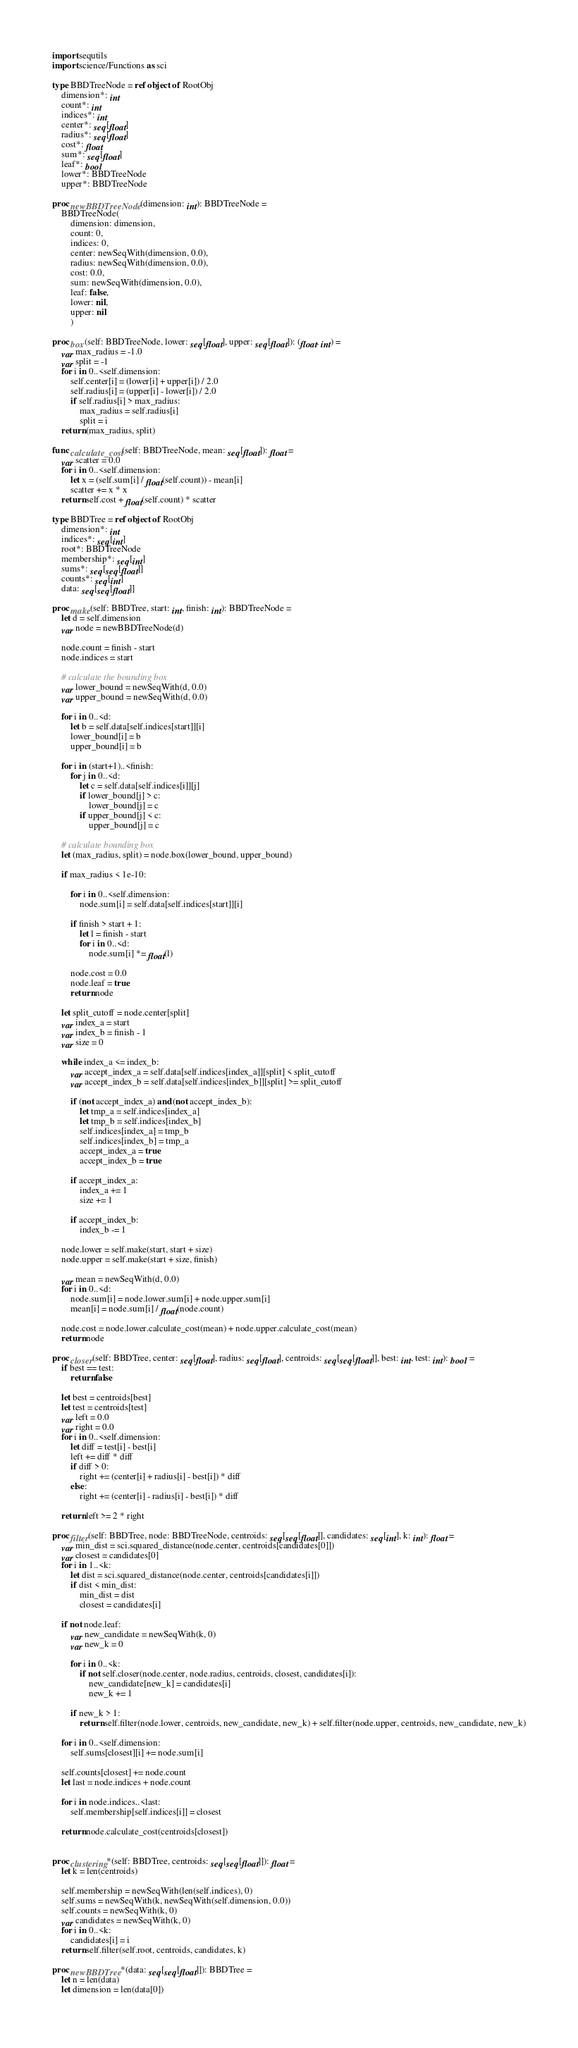<code> <loc_0><loc_0><loc_500><loc_500><_Nim_>import sequtils
import science/Functions as sci

type BBDTreeNode = ref object of RootObj
    dimension*: int
    count*: int
    indices*: int
    center*: seq[float]
    radius*: seq[float]
    cost*: float
    sum*: seq[float]
    leaf*: bool
    lower*: BBDTreeNode
    upper*: BBDTreeNode

proc newBBDTreeNode(dimension: int): BBDTreeNode =
    BBDTreeNode(
        dimension: dimension,
        count: 0,
        indices: 0,
        center: newSeqWith(dimension, 0.0),
        radius: newSeqWith(dimension, 0.0),
        cost: 0.0,
        sum: newSeqWith(dimension, 0.0),
        leaf: false,
        lower: nil,
        upper: nil
        )

proc box(self: BBDTreeNode, lower: seq[float], upper: seq[float]): (float, int) =
    var max_radius = -1.0
    var split = -1
    for i in 0..<self.dimension:
        self.center[i] = (lower[i] + upper[i]) / 2.0
        self.radius[i] = (upper[i] - lower[i]) / 2.0
        if self.radius[i] > max_radius:
            max_radius = self.radius[i]
            split = i
    return (max_radius, split)

func calculate_cost(self: BBDTreeNode, mean: seq[float]): float =
    var scatter = 0.0
    for i in 0..<self.dimension:
        let x = (self.sum[i] / float(self.count)) - mean[i]
        scatter += x * x
    return self.cost + float(self.count) * scatter

type BBDTree = ref object of RootObj
    dimension*: int
    indices*: seq[int]
    root*: BBDTreeNode
    membership*: seq[int]
    sums*: seq[seq[float]]
    counts*: seq[int]
    data: seq[seq[float]]

proc make(self: BBDTree, start: int, finish: int): BBDTreeNode =
    let d = self.dimension
    var node = newBBDTreeNode(d)

    node.count = finish - start
    node.indices = start

    # calculate the bounding box
    var lower_bound = newSeqWith(d, 0.0)
    var upper_bound = newSeqWith(d, 0.0)

    for i in 0..<d:
        let b = self.data[self.indices[start]][i]
        lower_bound[i] = b
        upper_bound[i] = b

    for i in (start+1)..<finish:
        for j in 0..<d:
            let c = self.data[self.indices[i]][j]
            if lower_bound[j] > c:
                lower_bound[j] = c
            if upper_bound[j] < c:
                upper_bound[j] = c
    
    # calculate bounding box
    let (max_radius, split) = node.box(lower_bound, upper_bound)

    if max_radius < 1e-10:

        for i in 0..<self.dimension:
            node.sum[i] = self.data[self.indices[start]][i]
            
        if finish > start + 1:
            let l = finish - start
            for i in 0..<d:
                node.sum[i] *= float(l)

        node.cost = 0.0
        node.leaf = true
        return node

    let split_cutoff = node.center[split]
    var index_a = start
    var index_b = finish - 1
    var size = 0

    while index_a <= index_b:
        var accept_index_a = self.data[self.indices[index_a]][split] < split_cutoff
        var accept_index_b = self.data[self.indices[index_b]][split] >= split_cutoff

        if (not accept_index_a) and (not accept_index_b):
            let tmp_a = self.indices[index_a]
            let tmp_b = self.indices[index_b]
            self.indices[index_a] = tmp_b
            self.indices[index_b] = tmp_a
            accept_index_a = true
            accept_index_b = true

        if accept_index_a:
            index_a += 1
            size += 1

        if accept_index_b:
            index_b -= 1
        
    node.lower = self.make(start, start + size)
    node.upper = self.make(start + size, finish)

    var mean = newSeqWith(d, 0.0)
    for i in 0..<d:
        node.sum[i] = node.lower.sum[i] + node.upper.sum[i]
        mean[i] = node.sum[i] / float(node.count)

    node.cost = node.lower.calculate_cost(mean) + node.upper.calculate_cost(mean)
    return node
    
proc closer(self: BBDTree, center: seq[float], radius: seq[float], centroids: seq[seq[float]], best: int, test: int): bool =
    if best == test:
        return false

    let best = centroids[best]
    let test = centroids[test]
    var left = 0.0
    var right = 0.0
    for i in 0..<self.dimension:
        let diff = test[i] - best[i]
        left += diff * diff
        if diff > 0:
            right += (center[i] + radius[i] - best[i]) * diff
        else:
            right += (center[i] - radius[i] - best[i]) * diff
    
    return left >= 2 * right

proc filter(self: BBDTree, node: BBDTreeNode, centroids: seq[seq[float]], candidates: seq[int], k: int): float =
    var min_dist = sci.squared_distance(node.center, centroids[candidates[0]])
    var closest = candidates[0]
    for i in 1..<k:
        let dist = sci.squared_distance(node.center, centroids[candidates[i]])
        if dist < min_dist:
            min_dist = dist
            closest = candidates[i]

    if not node.leaf:
        var new_candidate = newSeqWith(k, 0)
        var new_k = 0

        for i in 0..<k:
            if not self.closer(node.center, node.radius, centroids, closest, candidates[i]):
                new_candidate[new_k] = candidates[i]
                new_k += 1

        if new_k > 1:
            return self.filter(node.lower, centroids, new_candidate, new_k) + self.filter(node.upper, centroids, new_candidate, new_k)

    for i in 0..<self.dimension:
        self.sums[closest][i] += node.sum[i]

    self.counts[closest] += node.count
    let last = node.indices + node.count

    for i in node.indices..<last:
        self.membership[self.indices[i]] = closest

    return node.calculate_cost(centroids[closest])


proc clustering*(self: BBDTree, centroids: seq[seq[float]]): float =
    let k = len(centroids)

    self.membership = newSeqWith(len(self.indices), 0)
    self.sums = newSeqWith(k, newSeqWith(self.dimension, 0.0))
    self.counts = newSeqWith(k, 0)
    var candidates = newSeqWith(k, 0)
    for i in 0..<k:
        candidates[i] = i
    return self.filter(self.root, centroids, candidates, k)

proc newBBDTree*(data: seq[seq[float]]): BBDTree =
    let n = len(data)
    let dimension = len(data[0])</code> 